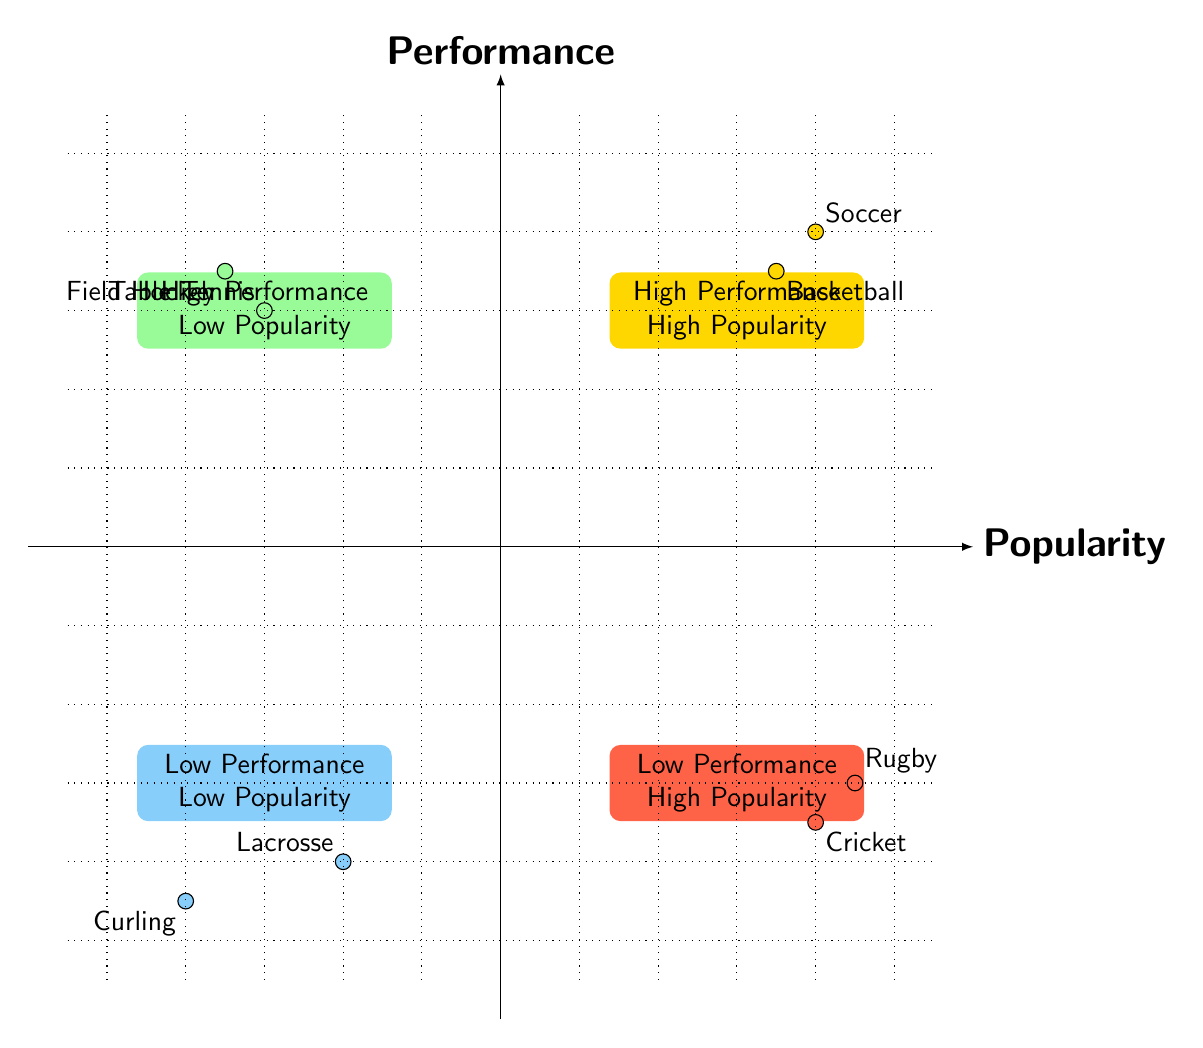What's the sport with the highest fan following in the High Performance - High Popularity quadrant? The sport in the High Performance - High Popularity quadrant with the highest fan following is Soccer, which has 80M fans.
Answer: Soccer How many sports are displayed in the Low Performance - Low Popularity quadrant? There are two sports displayed in the Low Performance - Low Popularity quadrant: Lacrosse and Curling.
Answer: 2 Which region has a famous team called "Boston Celtics"? The region where the famous team "Boston Celtics" is located is the Northeast region, as indicated in the High Performance - High Popularity quadrant.
Answer: Northeast What is the performance metric for Rugby as indicated in the diagram? The performance metric for Rugby is World Cup Wins, as stated in the Low Performance - High Popularity quadrant.
Answer: World Cup Wins Which sport in the High Performance - Low Popularity quadrant has a fan following of 5M? The sport in the High Performance - Low Popularity quadrant with a fan following of 5M is Table Tennis, according to the details provided.
Answer: Table Tennis Which quadrant contains sports that have high performance but low popularity? The quadrant that contains sports with high performance but low popularity is the High Performance - Low Popularity quadrant.
Answer: High Performance - Low Popularity What is the performance metric for Curling? The performance metric for Curling is World Titles, which is noted in the Low Performance - Low Popularity quadrant.
Answer: World Titles How many fans does the famous team "Mumbai Indians" have? The famous team "Mumbai Indians" has 85M fans, indicated in the Low Performance - High Popularity quadrant.
Answer: 85M 